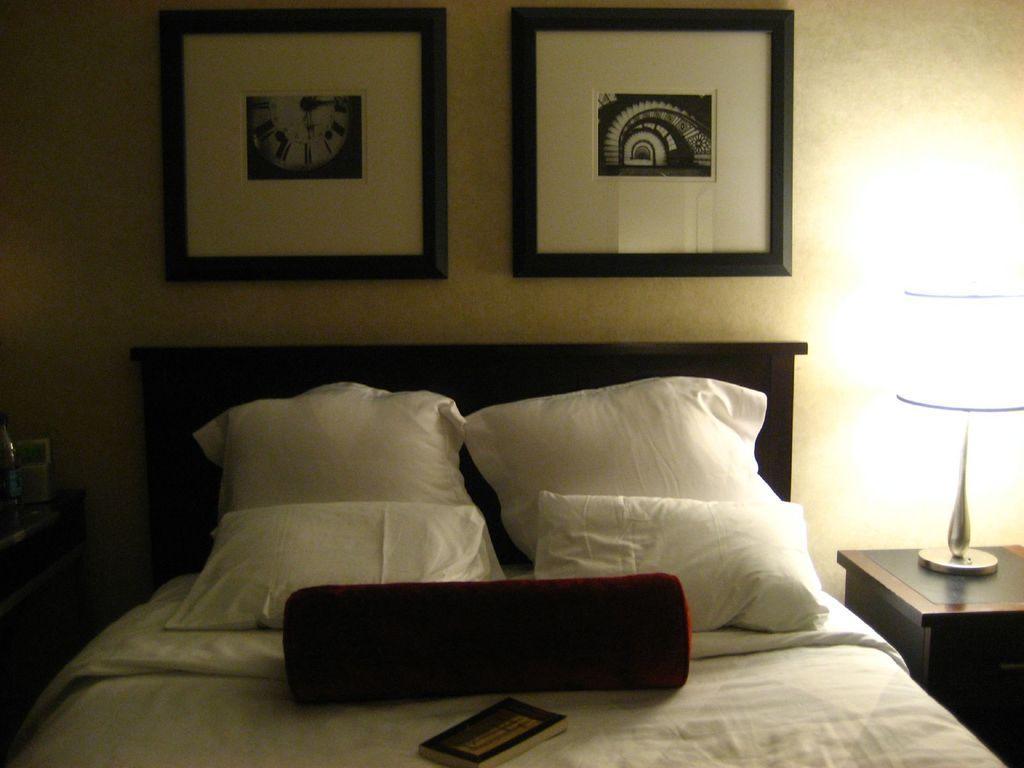In one or two sentences, can you explain what this image depicts? In this picture we can see a book on the bed and also we can see wall paintings and a light. 